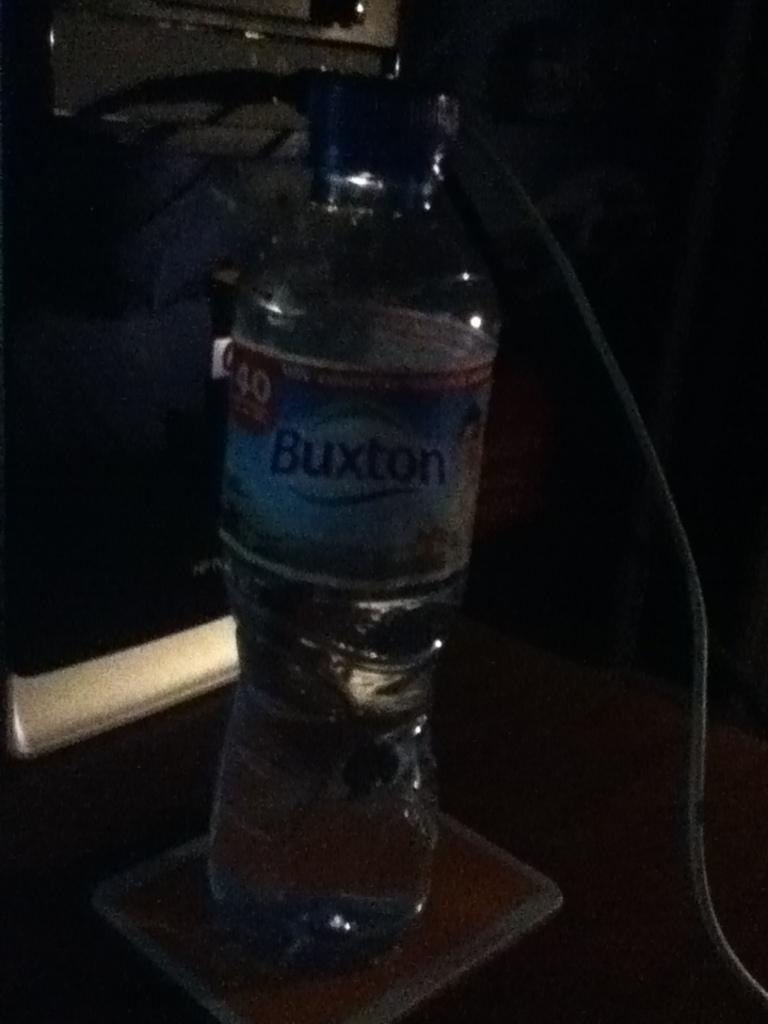<image>
Render a clear and concise summary of the photo. A water bottle that is dimly lit with the words Buxton on it. 